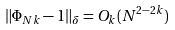Convert formula to latex. <formula><loc_0><loc_0><loc_500><loc_500>\| \Phi _ { N k } - 1 \| _ { \delta } = O _ { k } ( N ^ { 2 - 2 k } )</formula> 